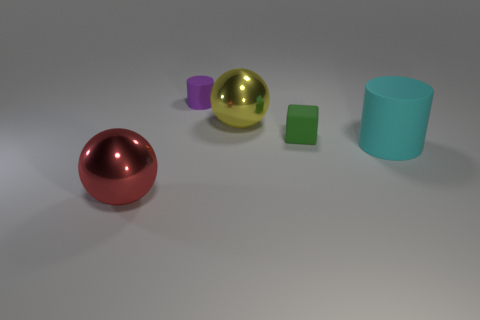Add 4 large cylinders. How many objects exist? 9 Subtract all cubes. How many objects are left? 4 Add 2 large cyan rubber cylinders. How many large cyan rubber cylinders are left? 3 Add 4 gray spheres. How many gray spheres exist? 4 Subtract 0 red blocks. How many objects are left? 5 Subtract all small purple cubes. Subtract all tiny purple matte cylinders. How many objects are left? 4 